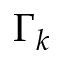Convert formula to latex. <formula><loc_0><loc_0><loc_500><loc_500>\Gamma _ { k }</formula> 